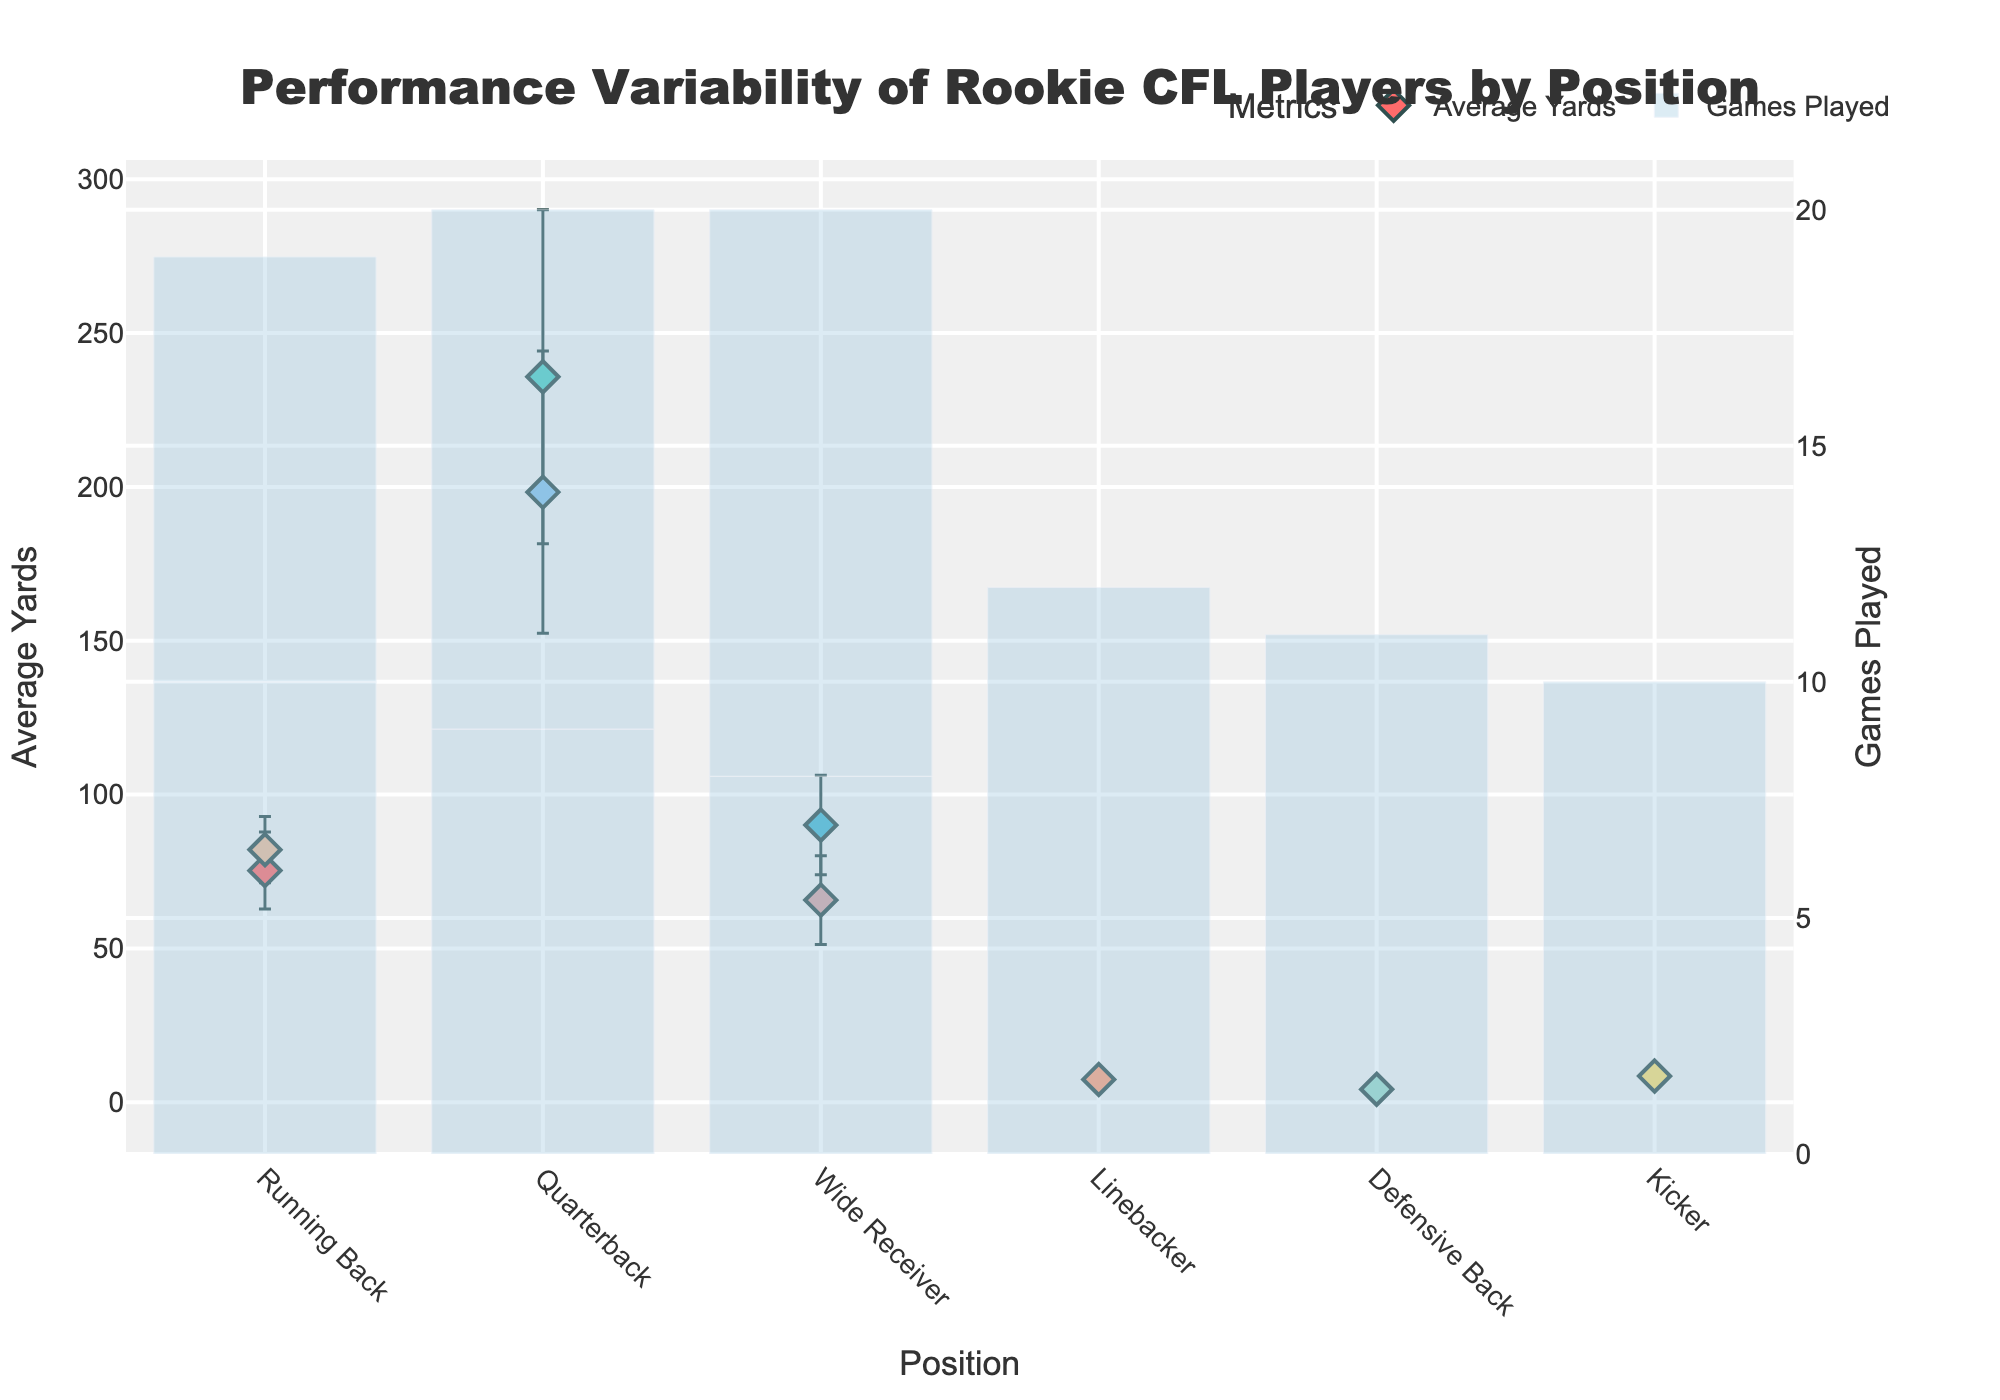What is the title of the chart? The title is located at the top of the chart. It provides an overview of the visual data being presented.
Answer: Performance Variability of Rookie CFL Players by Position How many different positions are displayed in the chart? To determine the number of different positions, count each unique label on the x-axis.
Answer: 6 Which player has the highest average yards? Look for the highest data point on the y-axis and match it with the corresponding player's position and name.
Answer: Liam Black What is the range of average yards for Wide Receivers? Identify all Wide Receivers, note their average yards, then calculate the difference between the highest and lowest values. Ethan Jackson (90.1), Benjamin Lee (65.7). 90.1 - 65.7 = 24.4
Answer: 24.4 Who had the most games played and what was their position? Observe the bar plot elements to identify the highest bar. Note the associated player and their position.
Answer: Noah Jones, Linebacker Which position shows the greatest performance variability in yards? The performance variability can be gauged by the length of the error bars. Longer error bars indicate greater variability.
Answer: Quarterback What is the difference in average yards between the highest and lowest performing Running Backs? Note the average yards for both Running Backs, then subtract the lowest value from the highest value. Henry Bennett (82.1) - Josh White (75.3) = 6.8
Answer: 6.8 Which position has the smallest error margin in game performance statistics? Compare the lengths of the error bars for all positions. The shortest error bar represents the smallest error margin.
Answer: Kicker Which player had the lowest average yards, and what position do they play? Identify the lowest data point on the y-axis and note the associated player and their position.
Answer: Oliver Brown, Defensive Back 